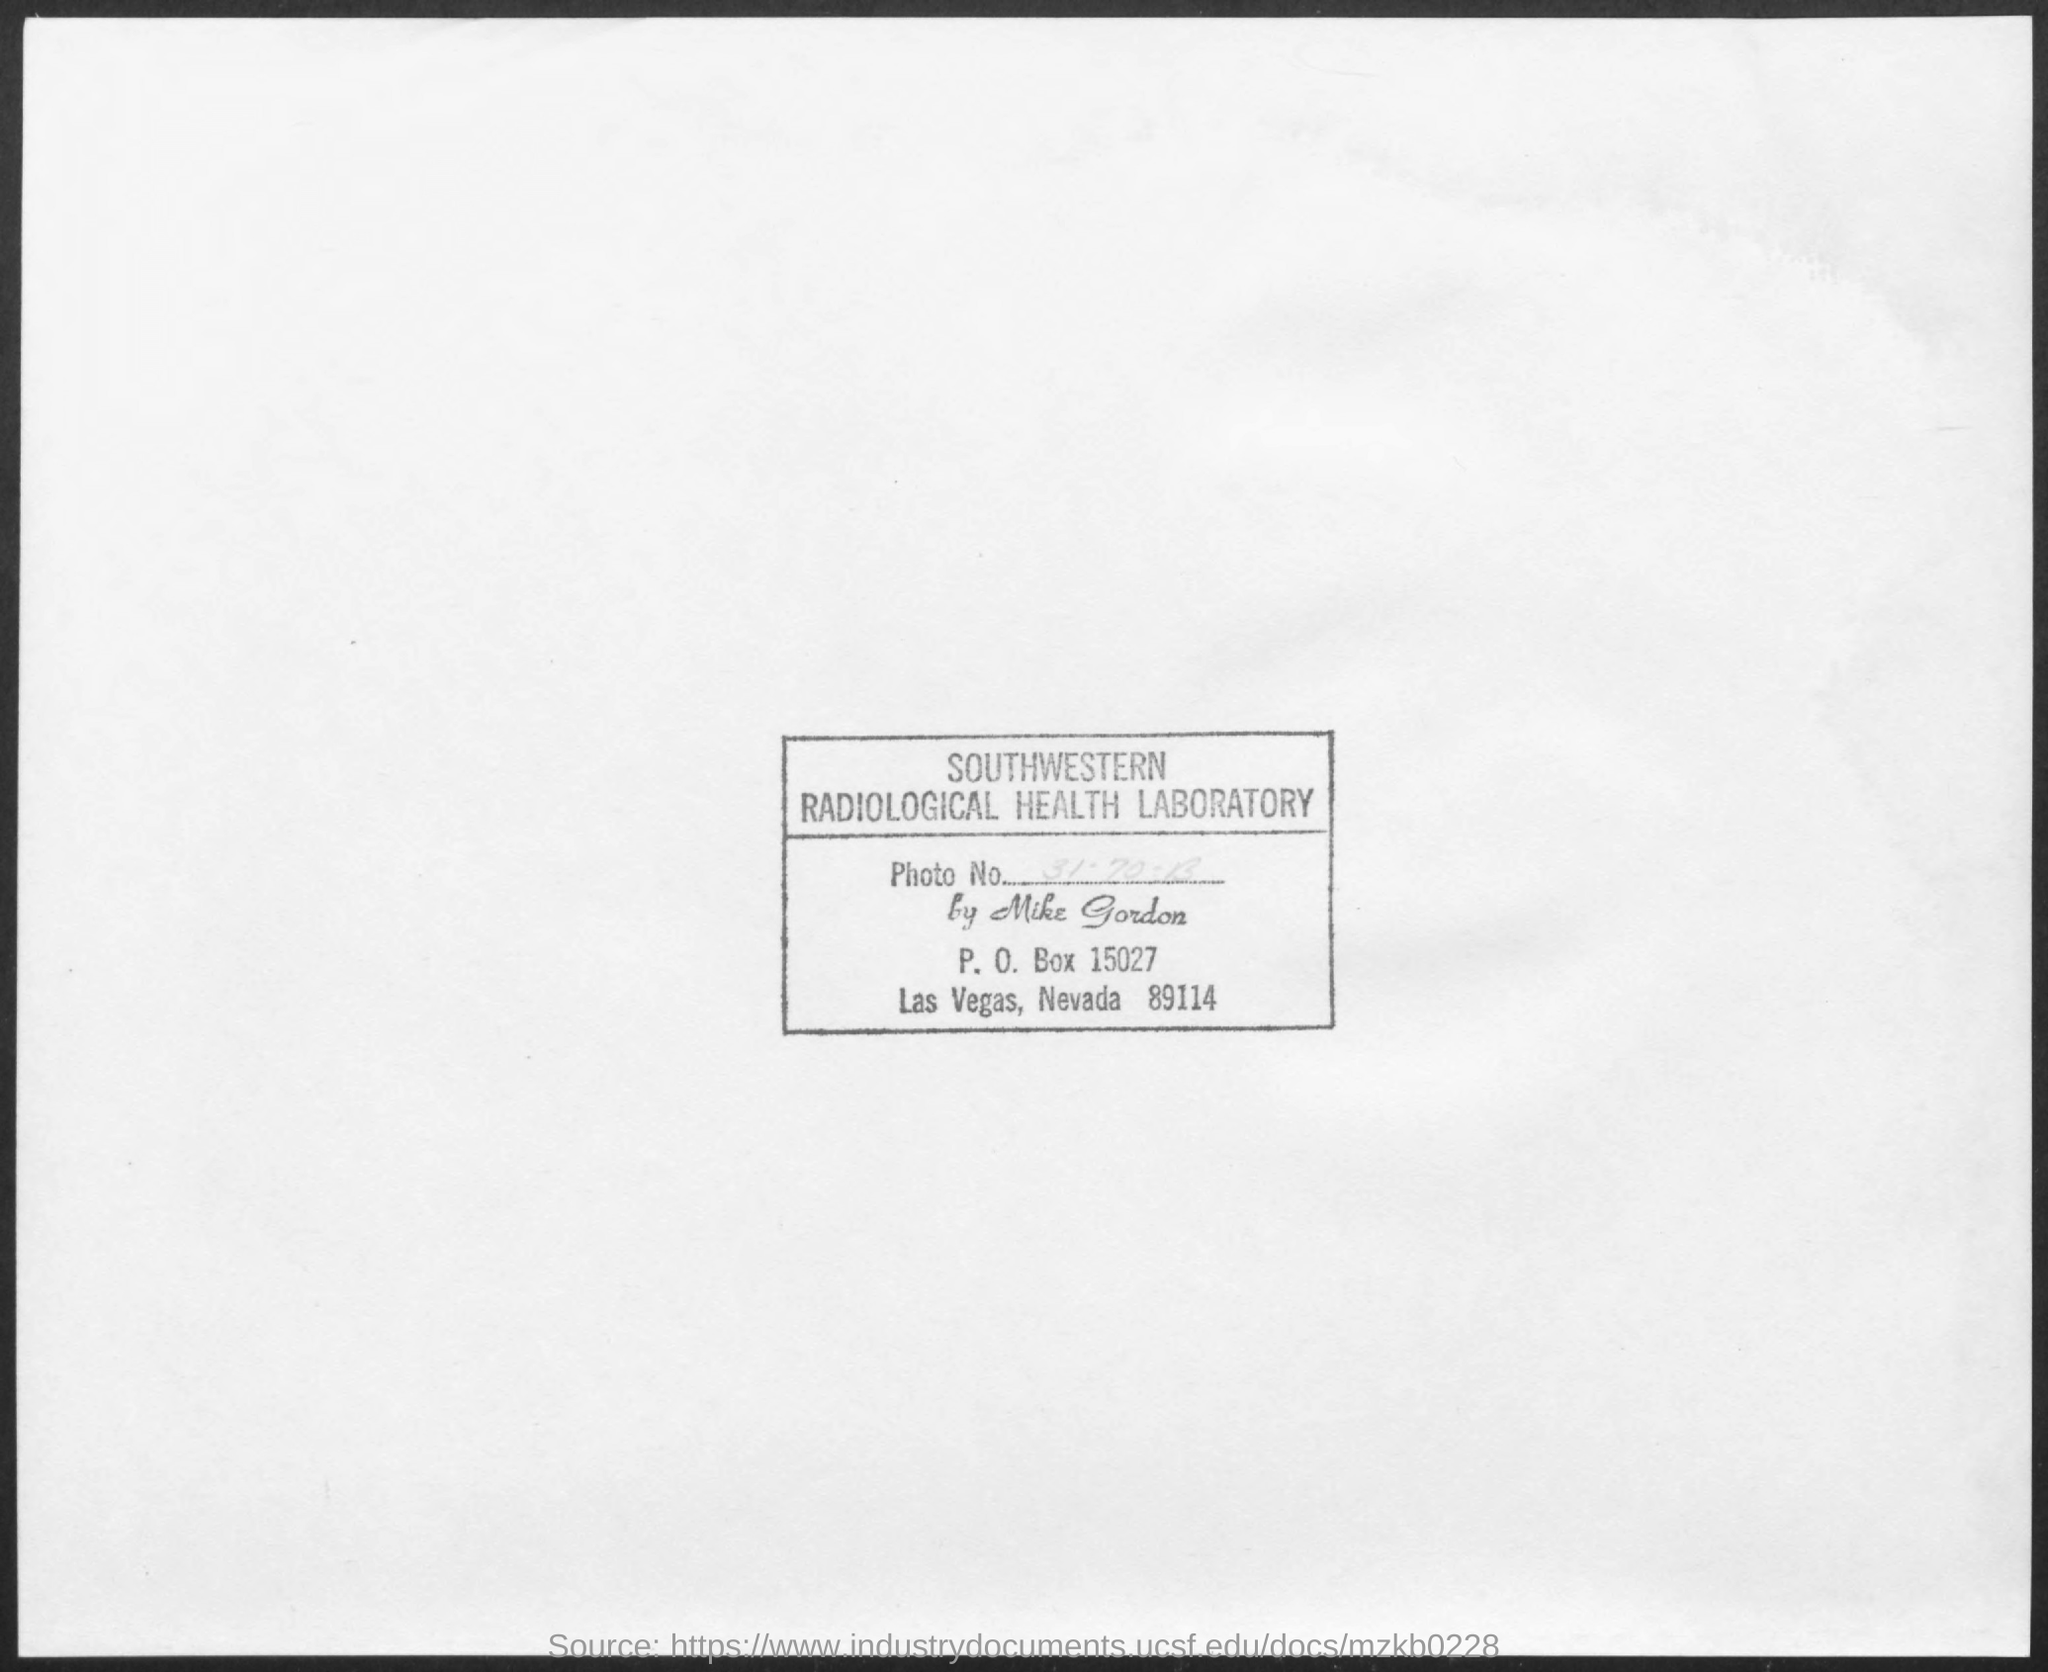What is the P. O. Box?
Give a very brief answer. 15027. What is the location?
Keep it short and to the point. Las Vegas, Nevada. 